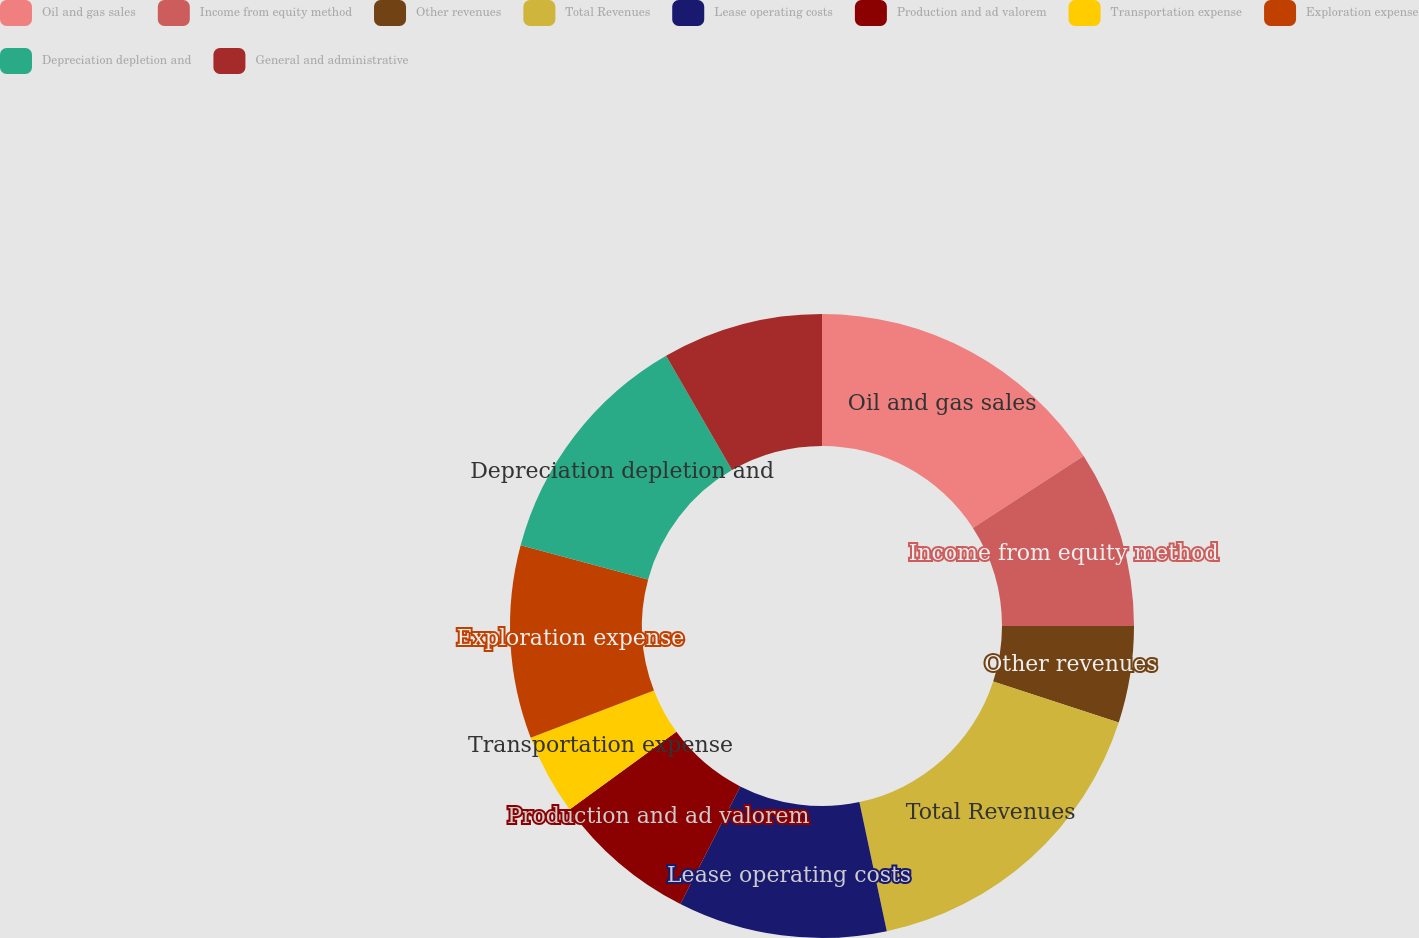Convert chart. <chart><loc_0><loc_0><loc_500><loc_500><pie_chart><fcel>Oil and gas sales<fcel>Income from equity method<fcel>Other revenues<fcel>Total Revenues<fcel>Lease operating costs<fcel>Production and ad valorem<fcel>Transportation expense<fcel>Exploration expense<fcel>Depreciation depletion and<fcel>General and administrative<nl><fcel>15.83%<fcel>9.17%<fcel>5.0%<fcel>16.67%<fcel>10.83%<fcel>7.5%<fcel>4.17%<fcel>10.0%<fcel>12.5%<fcel>8.33%<nl></chart> 